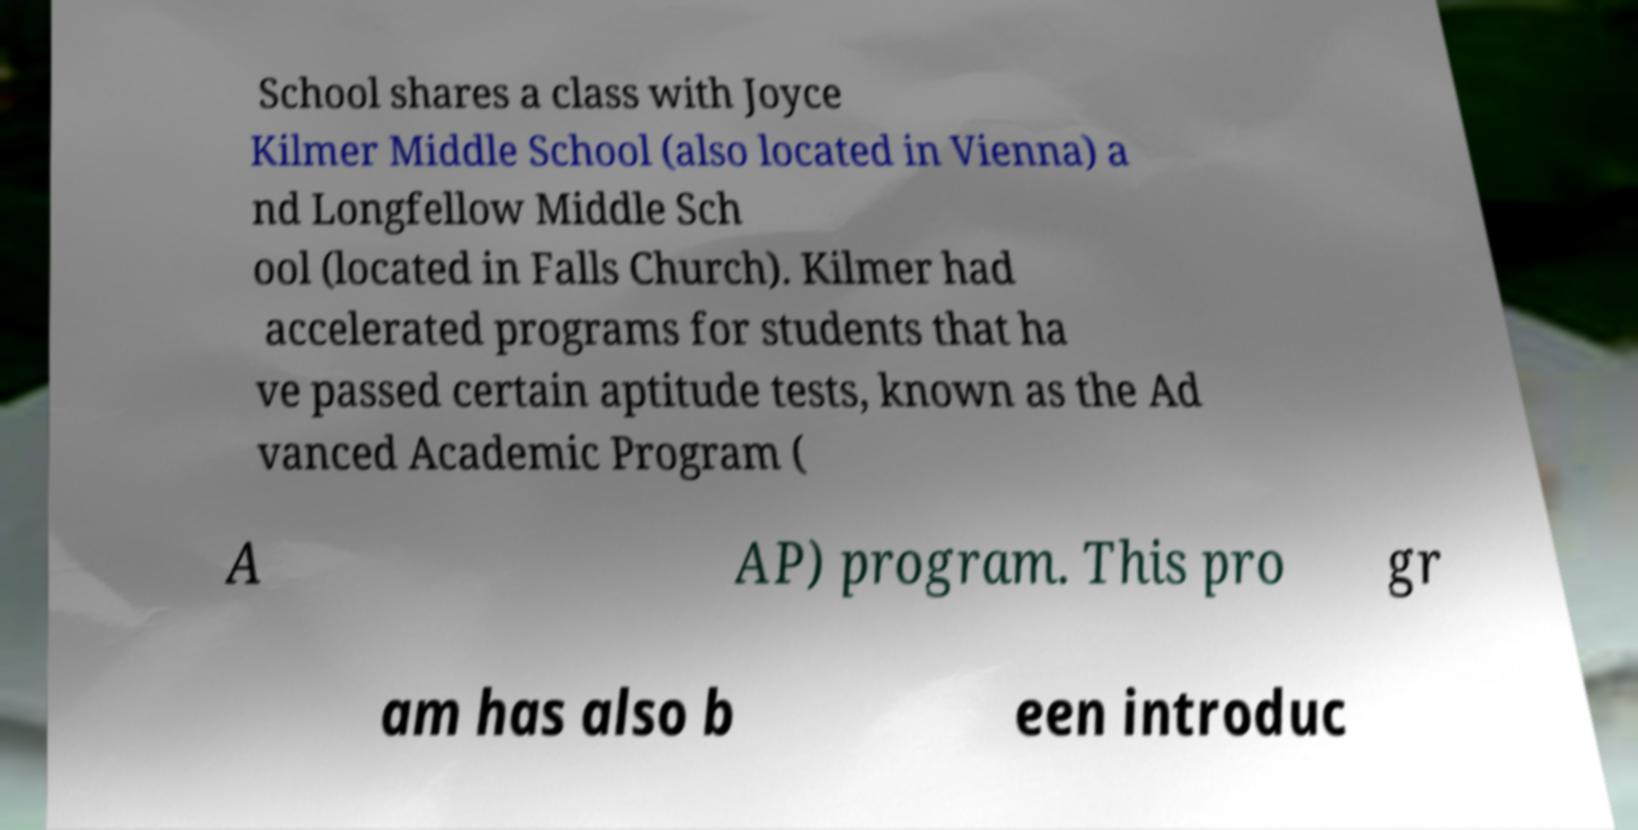What messages or text are displayed in this image? I need them in a readable, typed format. School shares a class with Joyce Kilmer Middle School (also located in Vienna) a nd Longfellow Middle Sch ool (located in Falls Church). Kilmer had accelerated programs for students that ha ve passed certain aptitude tests, known as the Ad vanced Academic Program ( A AP) program. This pro gr am has also b een introduc 